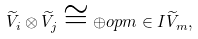Convert formula to latex. <formula><loc_0><loc_0><loc_500><loc_500>\widetilde { V } _ { i } \otimes \widetilde { V } _ { j } \cong \oplus o p { m \in I } \widetilde { V } _ { m } ,</formula> 